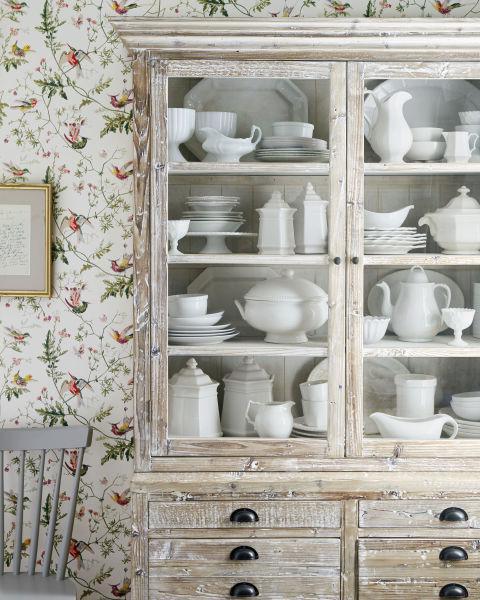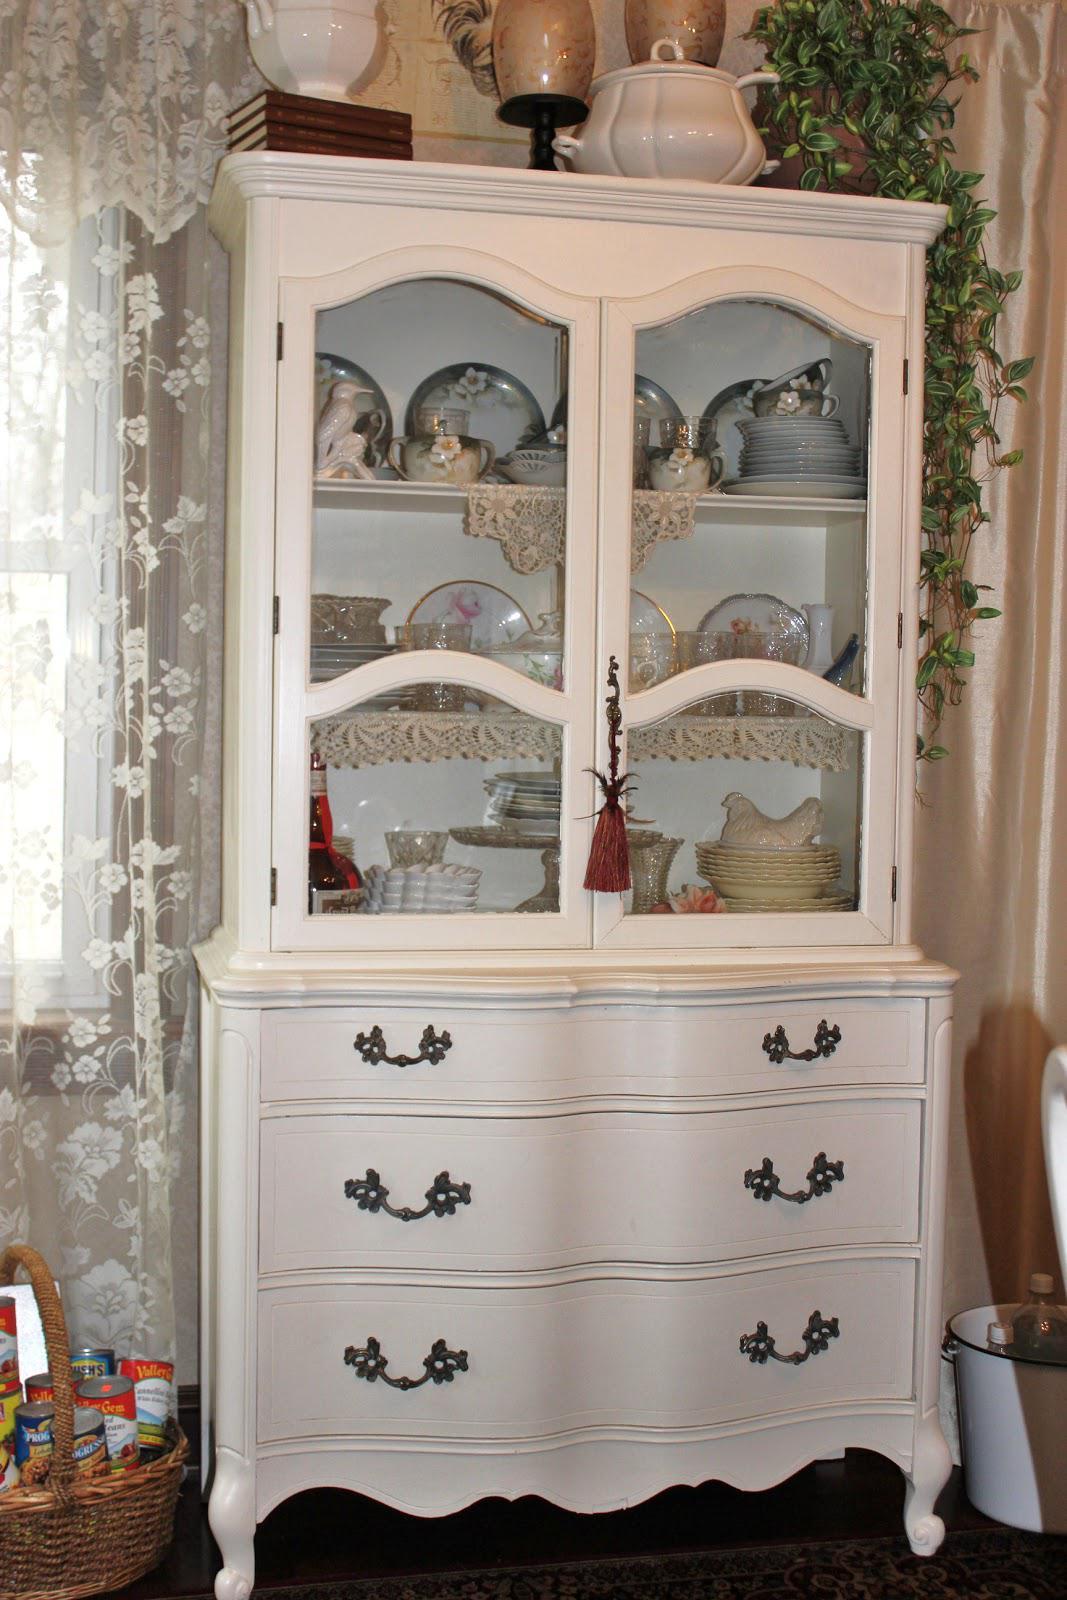The first image is the image on the left, the second image is the image on the right. For the images shown, is this caption "An image features a cabinet with an arched top and at least two glass doors." true? Answer yes or no. No. The first image is the image on the left, the second image is the image on the right. For the images shown, is this caption "One flat topped wooden hutch has the same number of glass doors in its upper section as solid doors in its lower section and sits flush to the floor." true? Answer yes or no. No. 